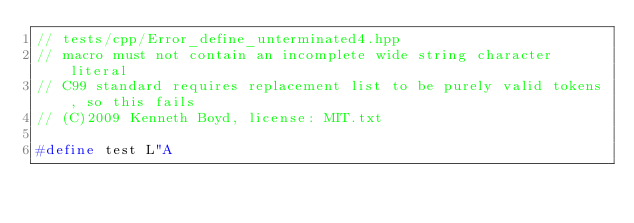Convert code to text. <code><loc_0><loc_0><loc_500><loc_500><_C_>// tests/cpp/Error_define_unterminated4.hpp
// macro must not contain an incomplete wide string character literal
// C99 standard requires replacement list to be purely valid tokens, so this fails
// (C)2009 Kenneth Boyd, license: MIT.txt

#define test L"A


</code> 